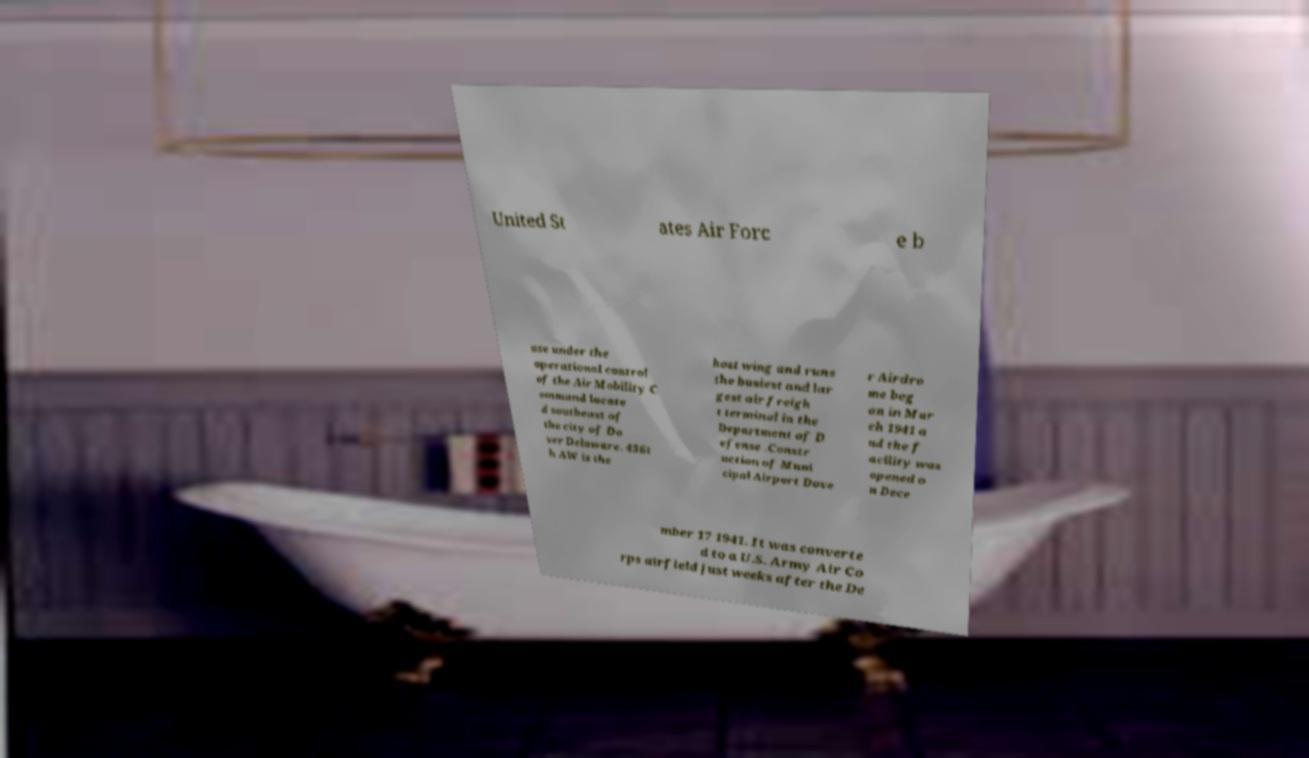I need the written content from this picture converted into text. Can you do that? United St ates Air Forc e b ase under the operational control of the Air Mobility C ommand locate d southeast of the city of Do ver Delaware. 436t h AW is the host wing and runs the busiest and lar gest air freigh t terminal in the Department of D efense .Constr uction of Muni cipal Airport Dove r Airdro me beg an in Mar ch 1941 a nd the f acility was opened o n Dece mber 17 1941. It was converte d to a U.S. Army Air Co rps airfield just weeks after the De 